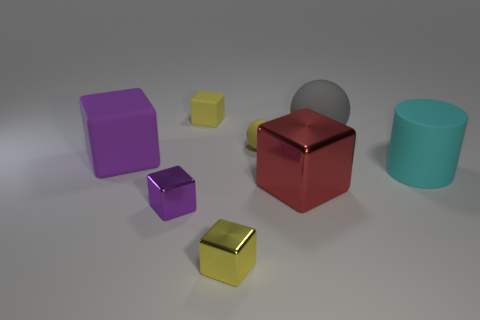Are there fewer gray rubber balls than small green matte things?
Offer a very short reply. No. Do the large red cube and the large cube that is to the left of the tiny rubber cube have the same material?
Keep it short and to the point. No. The small thing to the left of the tiny yellow matte cube has what shape?
Your answer should be very brief. Cube. Is there anything else of the same color as the large rubber block?
Make the answer very short. Yes. Is the number of tiny yellow matte spheres right of the cylinder less than the number of cyan cubes?
Keep it short and to the point. No. What number of yellow cubes are the same size as the yellow sphere?
Ensure brevity in your answer.  2. There is a small shiny object that is the same color as the big matte block; what shape is it?
Provide a short and direct response. Cube. What shape is the purple matte thing left of the matte sphere to the left of the large thing in front of the large cylinder?
Offer a terse response. Cube. What color is the cube on the right side of the yellow metallic block?
Your response must be concise. Red. What number of objects are yellow matte things behind the big gray object or tiny cubes in front of the tiny purple object?
Keep it short and to the point. 2. 